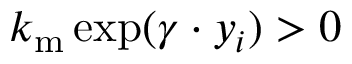Convert formula to latex. <formula><loc_0><loc_0><loc_500><loc_500>k _ { m } \exp ( \gamma \cdot y _ { i } ) > 0</formula> 